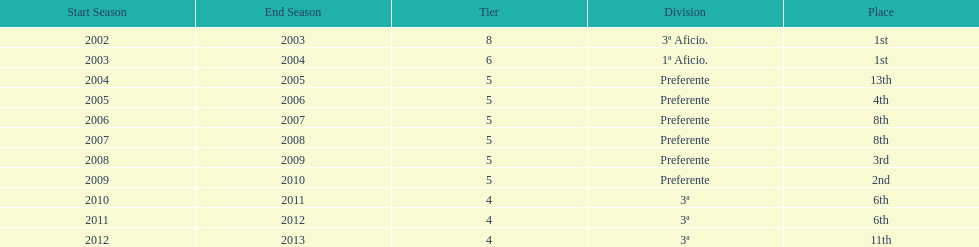Which division has the largest number of ranks? Preferente. 